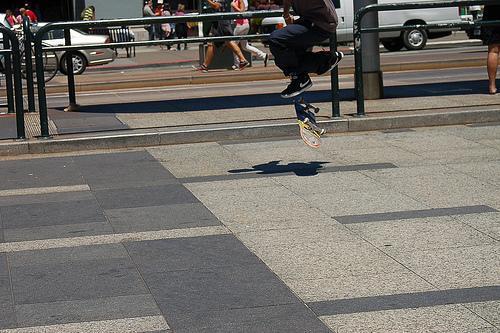How many skateboards are there?
Give a very brief answer. 1. 